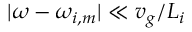<formula> <loc_0><loc_0><loc_500><loc_500>| \omega - \omega _ { i , m } | \ll { v _ { g } } / { L _ { i } }</formula> 